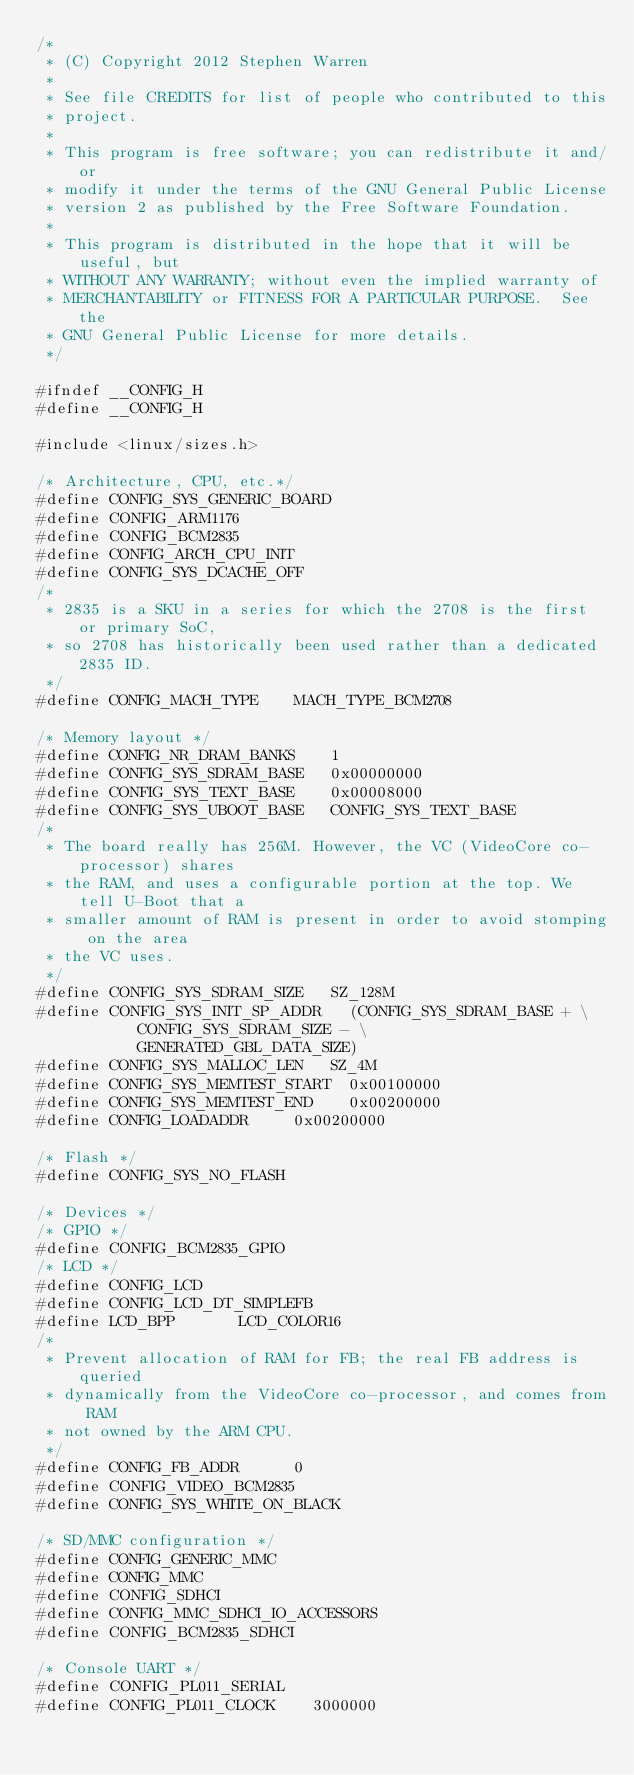<code> <loc_0><loc_0><loc_500><loc_500><_C_>/*
 * (C) Copyright 2012 Stephen Warren
 *
 * See file CREDITS for list of people who contributed to this
 * project.
 *
 * This program is free software; you can redistribute it and/or
 * modify it under the terms of the GNU General Public License
 * version 2 as published by the Free Software Foundation.
 *
 * This program is distributed in the hope that it will be useful, but
 * WITHOUT ANY WARRANTY; without even the implied warranty of
 * MERCHANTABILITY or FITNESS FOR A PARTICULAR PURPOSE.  See the
 * GNU General Public License for more details.
 */

#ifndef __CONFIG_H
#define __CONFIG_H

#include <linux/sizes.h>

/* Architecture, CPU, etc.*/
#define CONFIG_SYS_GENERIC_BOARD
#define CONFIG_ARM1176
#define CONFIG_BCM2835
#define CONFIG_ARCH_CPU_INIT
#define CONFIG_SYS_DCACHE_OFF
/*
 * 2835 is a SKU in a series for which the 2708 is the first or primary SoC,
 * so 2708 has historically been used rather than a dedicated 2835 ID.
 */
#define CONFIG_MACH_TYPE		MACH_TYPE_BCM2708

/* Memory layout */
#define CONFIG_NR_DRAM_BANKS		1
#define CONFIG_SYS_SDRAM_BASE		0x00000000
#define CONFIG_SYS_TEXT_BASE		0x00008000
#define CONFIG_SYS_UBOOT_BASE		CONFIG_SYS_TEXT_BASE
/*
 * The board really has 256M. However, the VC (VideoCore co-processor) shares
 * the RAM, and uses a configurable portion at the top. We tell U-Boot that a
 * smaller amount of RAM is present in order to avoid stomping on the area
 * the VC uses.
 */
#define CONFIG_SYS_SDRAM_SIZE		SZ_128M
#define CONFIG_SYS_INIT_SP_ADDR		(CONFIG_SYS_SDRAM_BASE + \
					 CONFIG_SYS_SDRAM_SIZE - \
					 GENERATED_GBL_DATA_SIZE)
#define CONFIG_SYS_MALLOC_LEN		SZ_4M
#define CONFIG_SYS_MEMTEST_START	0x00100000
#define CONFIG_SYS_MEMTEST_END		0x00200000
#define CONFIG_LOADADDR			0x00200000

/* Flash */
#define CONFIG_SYS_NO_FLASH

/* Devices */
/* GPIO */
#define CONFIG_BCM2835_GPIO
/* LCD */
#define CONFIG_LCD
#define CONFIG_LCD_DT_SIMPLEFB
#define LCD_BPP				LCD_COLOR16
/*
 * Prevent allocation of RAM for FB; the real FB address is queried
 * dynamically from the VideoCore co-processor, and comes from RAM
 * not owned by the ARM CPU.
 */
#define CONFIG_FB_ADDR			0
#define CONFIG_VIDEO_BCM2835
#define CONFIG_SYS_WHITE_ON_BLACK

/* SD/MMC configuration */
#define CONFIG_GENERIC_MMC
#define CONFIG_MMC
#define CONFIG_SDHCI
#define CONFIG_MMC_SDHCI_IO_ACCESSORS
#define CONFIG_BCM2835_SDHCI

/* Console UART */
#define CONFIG_PL011_SERIAL
#define CONFIG_PL011_CLOCK		3000000</code> 